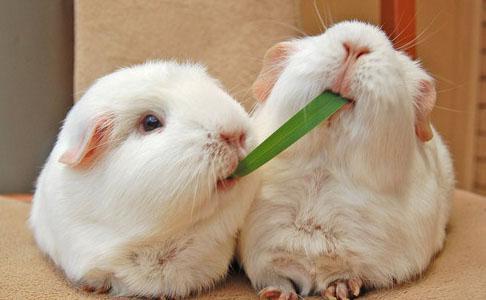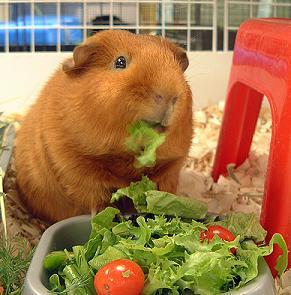The first image is the image on the left, the second image is the image on the right. Examine the images to the left and right. Is the description "The right image contains exactly two rodents." accurate? Answer yes or no. No. The first image is the image on the left, the second image is the image on the right. Given the left and right images, does the statement "All guinea pigs are on green grass, and none of them are standing upright." hold true? Answer yes or no. No. 